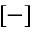Convert formula to latex. <formula><loc_0><loc_0><loc_500><loc_500>[ - ]</formula> 